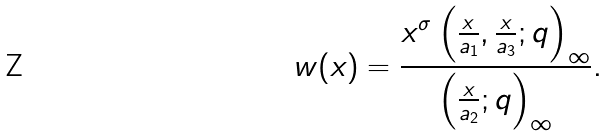<formula> <loc_0><loc_0><loc_500><loc_500>w ( x ) = \frac { x ^ { \sigma } \left ( \frac { x } { a _ { 1 } } , \frac { x } { a _ { 3 } } ; q \right ) _ { \infty } } { \left ( \frac { x } { a _ { 2 } } ; q \right ) _ { \infty } } .</formula> 